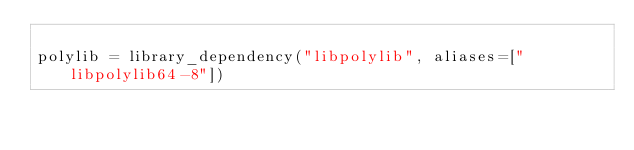Convert code to text. <code><loc_0><loc_0><loc_500><loc_500><_Julia_>
polylib = library_dependency("libpolylib", aliases=["libpolylib64-8"])</code> 